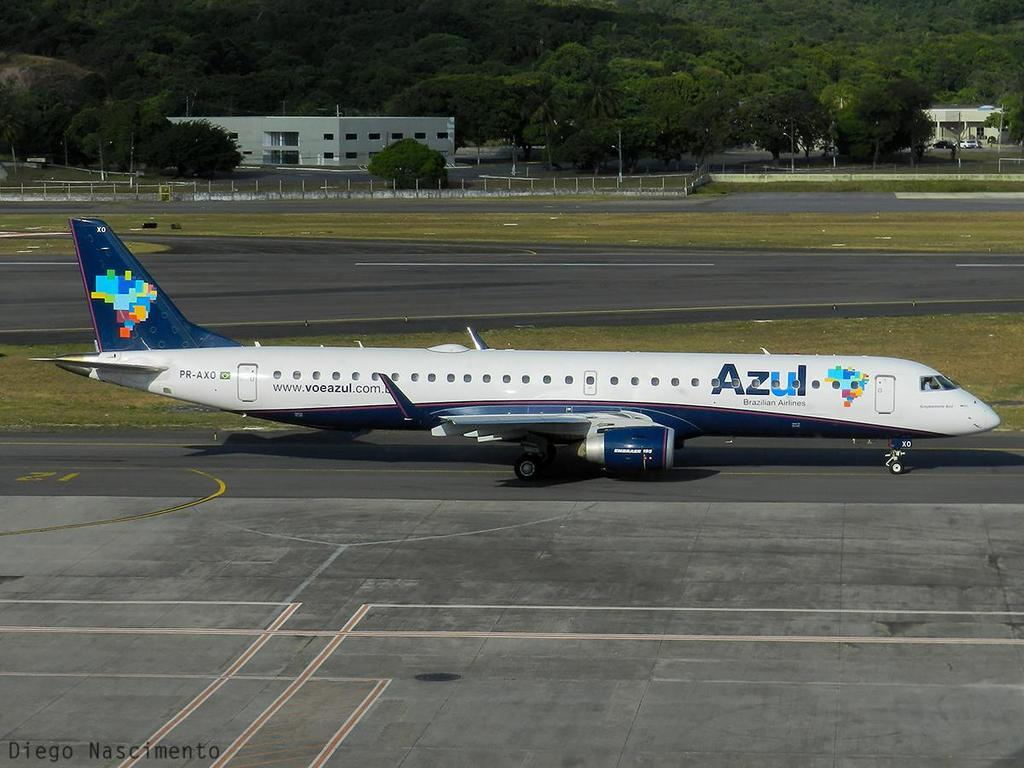What is the main subject of the image? The main subject of the image is an airplane on the runway. What part of the airplane can be seen in the image? The cockpit and rudder of the airplane are visible in the image. What type of vegetation is present in the image? There is grass in the image. What type of structure is visible in the image? There is a building in the image. What other natural elements are present in the image? There are trees in the image. What type of pancake is being served on the airplane in the image? There is no pancake present in the image; it features an airplane on the runway with its cockpit and rudder visible. What flag is being flown by the airplane in the image? There is no flag present in the image; it only shows an airplane on the runway with its cockpit and rudder visible. 